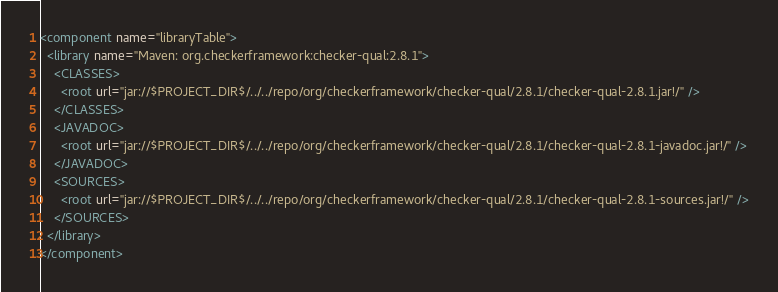<code> <loc_0><loc_0><loc_500><loc_500><_XML_><component name="libraryTable">
  <library name="Maven: org.checkerframework:checker-qual:2.8.1">
    <CLASSES>
      <root url="jar://$PROJECT_DIR$/../../repo/org/checkerframework/checker-qual/2.8.1/checker-qual-2.8.1.jar!/" />
    </CLASSES>
    <JAVADOC>
      <root url="jar://$PROJECT_DIR$/../../repo/org/checkerframework/checker-qual/2.8.1/checker-qual-2.8.1-javadoc.jar!/" />
    </JAVADOC>
    <SOURCES>
      <root url="jar://$PROJECT_DIR$/../../repo/org/checkerframework/checker-qual/2.8.1/checker-qual-2.8.1-sources.jar!/" />
    </SOURCES>
  </library>
</component></code> 